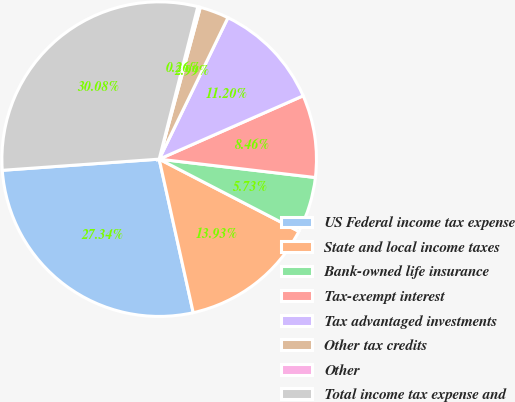<chart> <loc_0><loc_0><loc_500><loc_500><pie_chart><fcel>US Federal income tax expense<fcel>State and local income taxes<fcel>Bank-owned life insurance<fcel>Tax-exempt interest<fcel>Tax advantaged investments<fcel>Other tax credits<fcel>Other<fcel>Total income tax expense and<nl><fcel>27.34%<fcel>13.93%<fcel>5.73%<fcel>8.46%<fcel>11.2%<fcel>2.99%<fcel>0.26%<fcel>30.08%<nl></chart> 